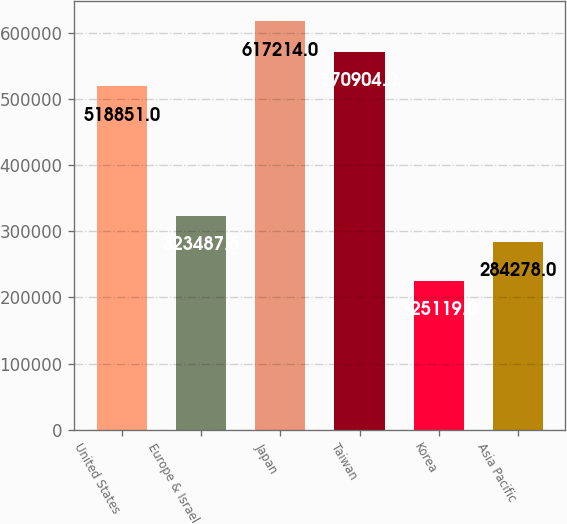<chart> <loc_0><loc_0><loc_500><loc_500><bar_chart><fcel>United States<fcel>Europe & Israel<fcel>Japan<fcel>Taiwan<fcel>Korea<fcel>Asia Pacific<nl><fcel>518851<fcel>323488<fcel>617214<fcel>570904<fcel>225119<fcel>284278<nl></chart> 